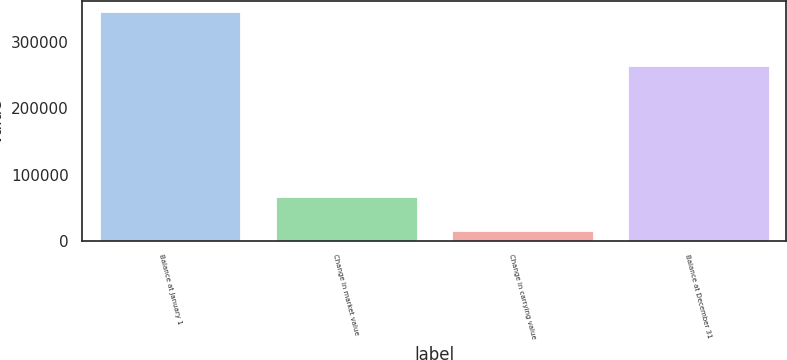Convert chart to OTSL. <chart><loc_0><loc_0><loc_500><loc_500><bar_chart><fcel>Balance at January 1<fcel>Change in market value<fcel>Change in carrying value<fcel>Balance at December 31<nl><fcel>345165<fcel>65524<fcel>15247<fcel>264394<nl></chart> 